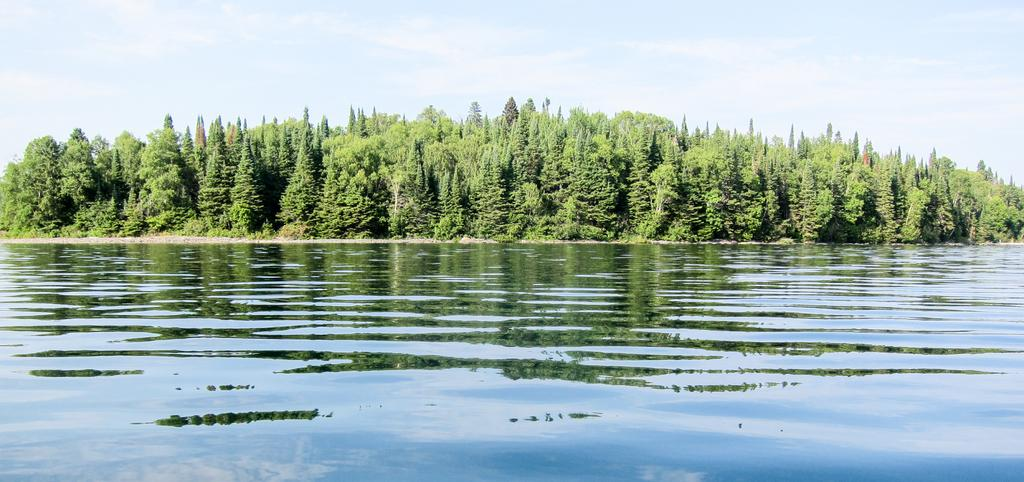What type of vegetation can be seen near the lake in the image? There is a tree beside the lake in the image. What is visible at the top of the image? The sky is visible at the top of the image. What type of lipstick is being used to paint the tree in the image? There is no lipstick or painting activity present in the image; it features a tree beside a lake. What type of destruction can be seen happening to the plants in the image? There is no destruction or damage to plants visible in the image; the tree appears to be intact. 